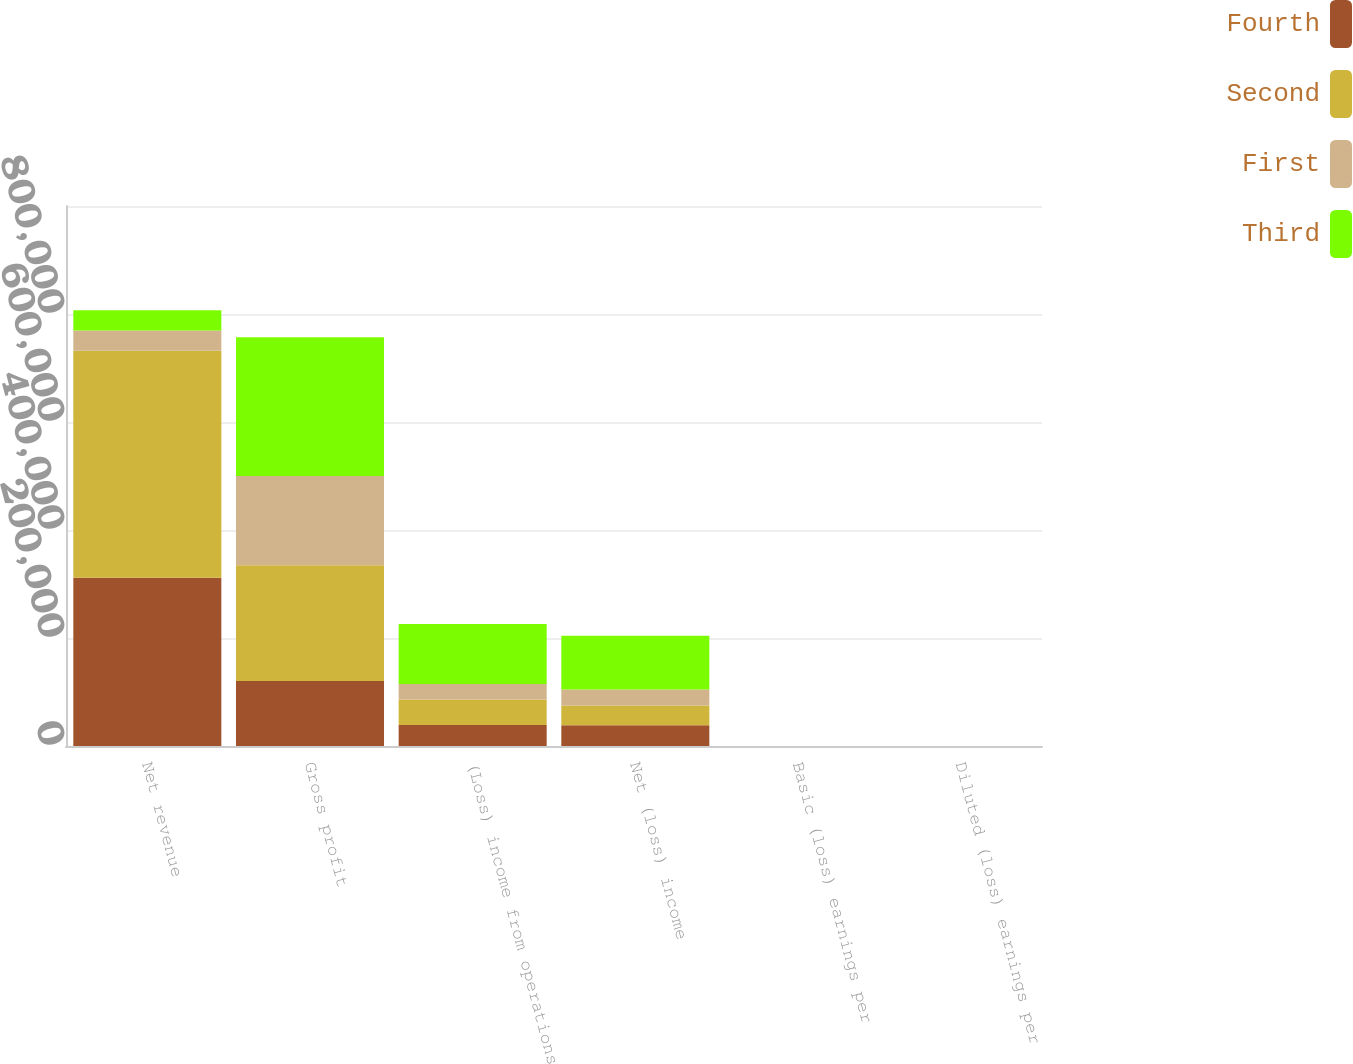Convert chart. <chart><loc_0><loc_0><loc_500><loc_500><stacked_bar_chart><ecel><fcel>Net revenue<fcel>Gross profit<fcel>(Loss) income from operations<fcel>Net (loss) income<fcel>Basic (loss) earnings per<fcel>Diluted (loss) earnings per<nl><fcel>Fourth<fcel>311552<fcel>120171<fcel>38983<fcel>38567<fcel>0.46<fcel>0.46<nl><fcel>Second<fcel>420167<fcel>214562<fcel>47194<fcel>36432<fcel>0.42<fcel>0.39<nl><fcel>First<fcel>37499.5<fcel>165399<fcel>28409<fcel>29842<fcel>0.33<fcel>0.33<nl><fcel>Third<fcel>37499.5<fcel>256657<fcel>111503<fcel>99280<fcel>0.97<fcel>0.89<nl></chart> 